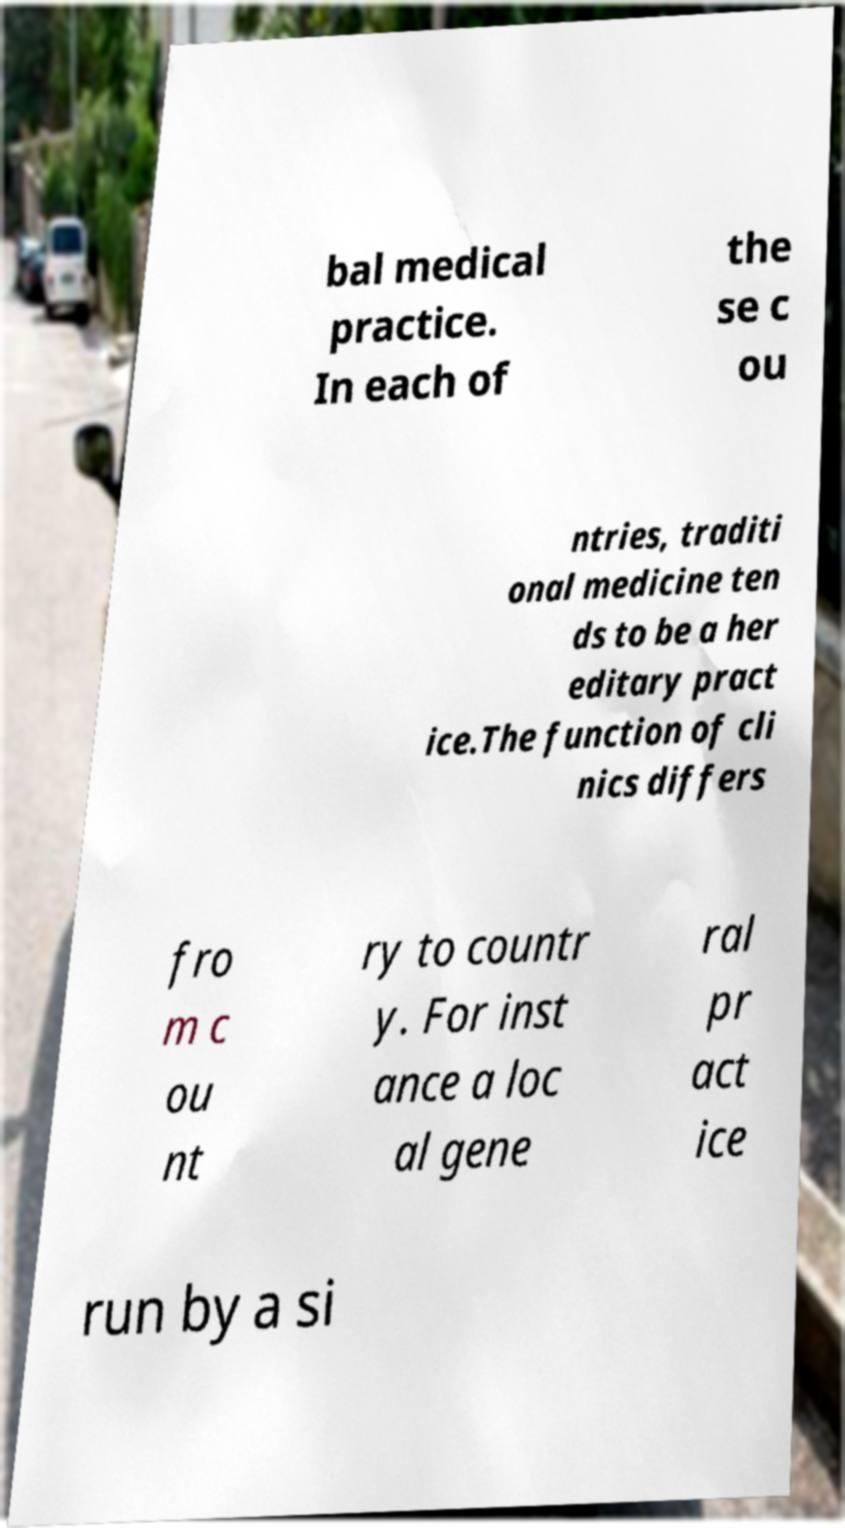There's text embedded in this image that I need extracted. Can you transcribe it verbatim? bal medical practice. In each of the se c ou ntries, traditi onal medicine ten ds to be a her editary pract ice.The function of cli nics differs fro m c ou nt ry to countr y. For inst ance a loc al gene ral pr act ice run by a si 